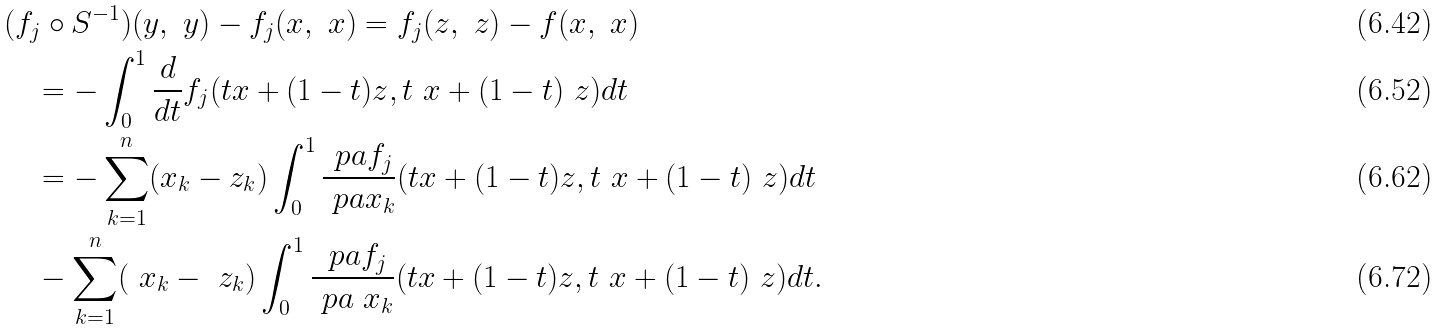<formula> <loc_0><loc_0><loc_500><loc_500>& ( f _ { j } \circ S ^ { - 1 } ) ( y , \ y ) - f _ { j } ( x , \ x ) = f _ { j } ( z , \ z ) - f ( x , \ x ) \\ & \quad = - \int _ { 0 } ^ { 1 } \frac { d } { d t } f _ { j } ( t x + ( 1 - t ) z , t \ x + ( 1 - t ) \ z ) d t \\ & \quad = - \sum _ { k = 1 } ^ { n } ( x _ { k } - z _ { k } ) \int _ { 0 } ^ { 1 } \frac { \ p a f _ { j } } { \ p a x _ { k } } ( t x + ( 1 - t ) z , t \ x + ( 1 - t ) \ z ) d t \\ & \quad - \sum _ { k = 1 } ^ { n } ( \ x _ { k } - \ z _ { k } ) \int _ { 0 } ^ { 1 } \frac { \ p a f _ { j } } { \ p a \ x _ { k } } ( t x + ( 1 - t ) z , t \ x + ( 1 - t ) \ z ) d t .</formula> 